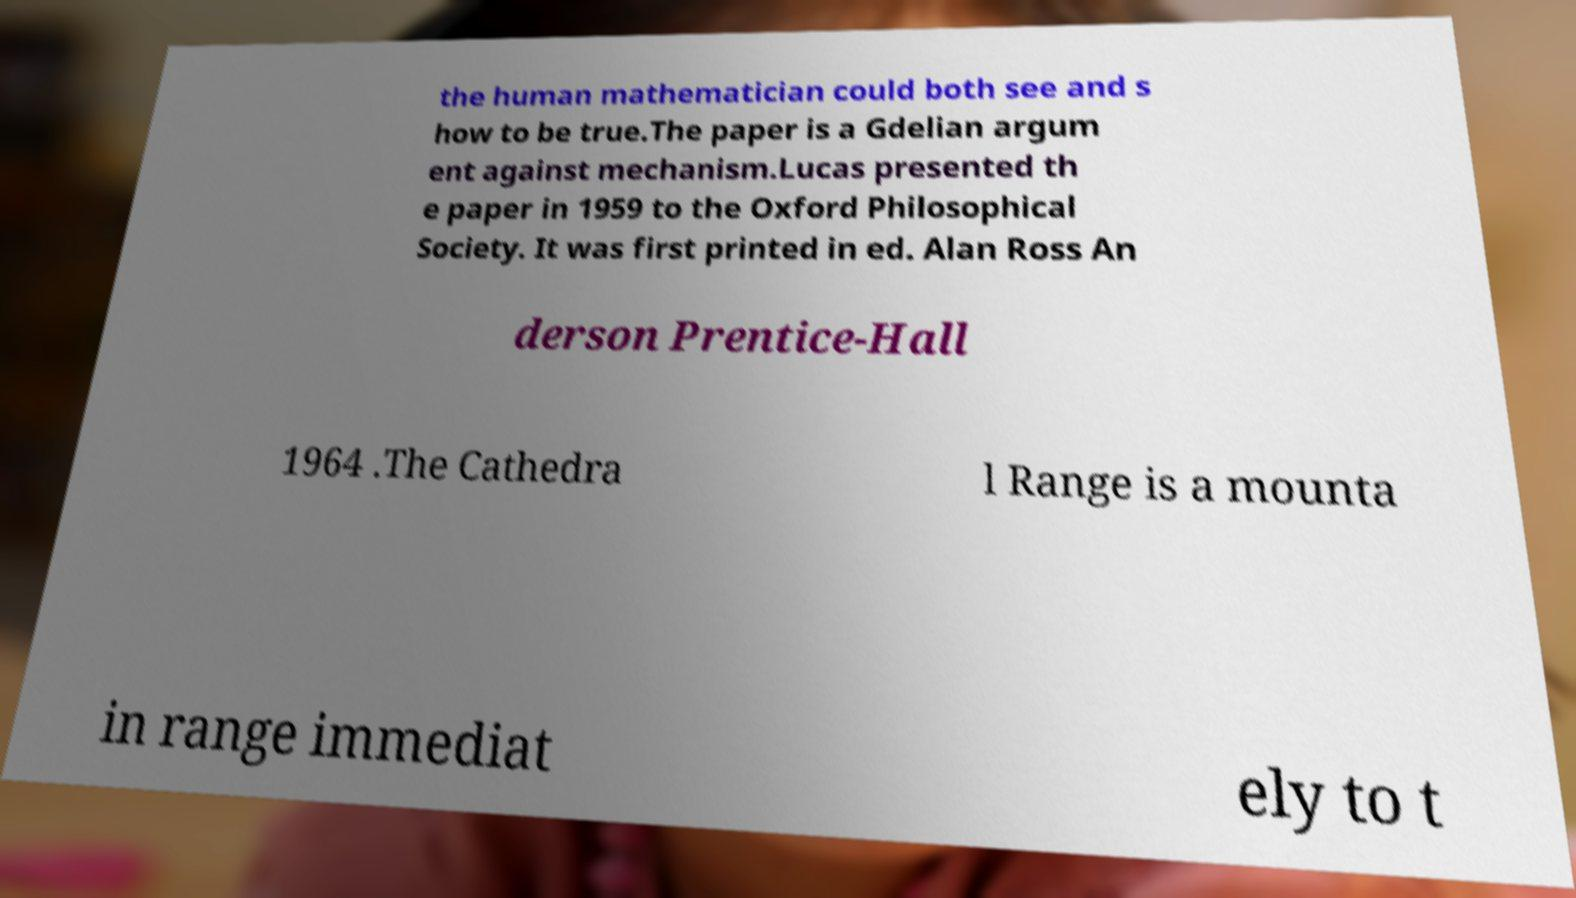Please read and relay the text visible in this image. What does it say? the human mathematician could both see and s how to be true.The paper is a Gdelian argum ent against mechanism.Lucas presented th e paper in 1959 to the Oxford Philosophical Society. It was first printed in ed. Alan Ross An derson Prentice-Hall 1964 .The Cathedra l Range is a mounta in range immediat ely to t 